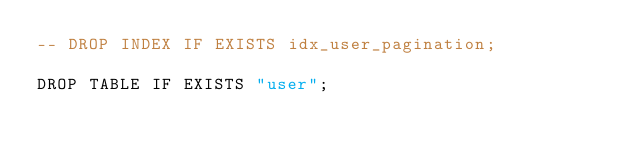Convert code to text. <code><loc_0><loc_0><loc_500><loc_500><_SQL_>-- DROP INDEX IF EXISTS idx_user_pagination;

DROP TABLE IF EXISTS "user";</code> 